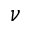<formula> <loc_0><loc_0><loc_500><loc_500>\nu</formula> 